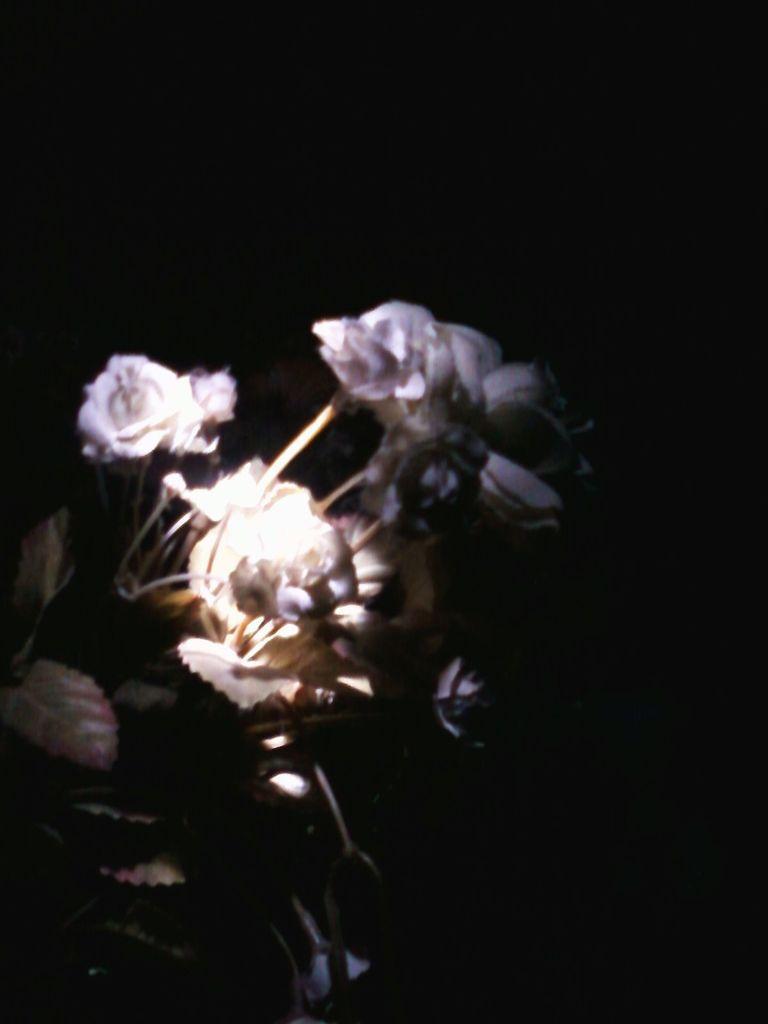Can you describe this image briefly? In this image we can see planets with some flowers on it and the background is dark. 